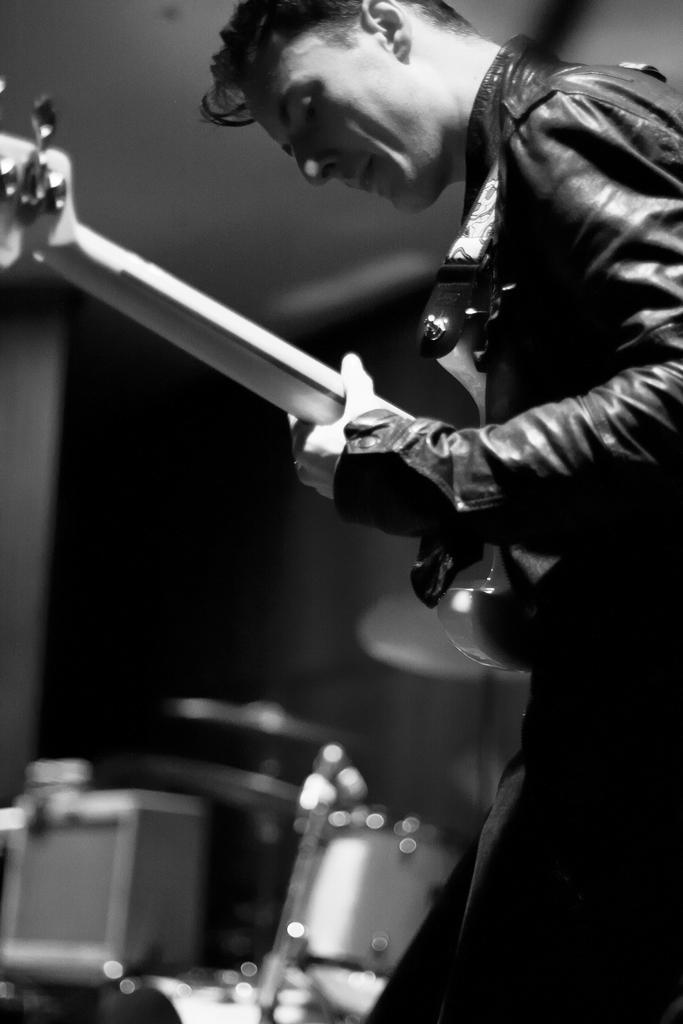Please provide a concise description of this image. In this image I can see a man is standing and holding a guitar, I can also see he is wearing a jacket and in the background I can see a drum set. 